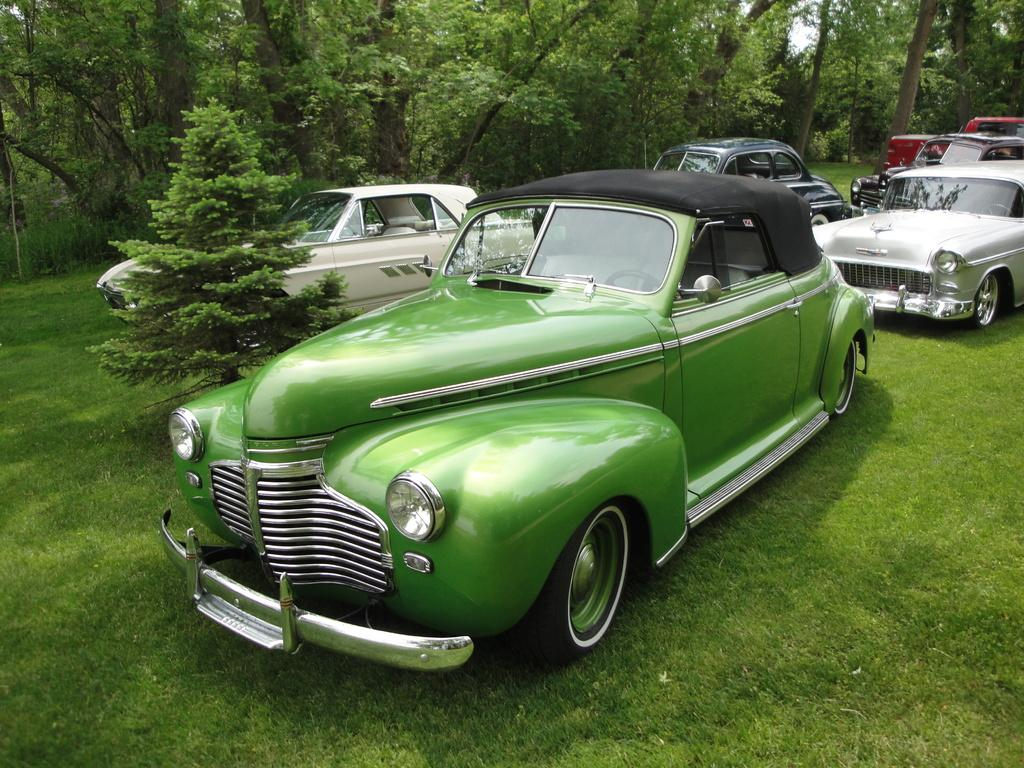What is located on the grass in the image? There are vehicles on the grass in the image. What type of natural elements can be seen in the image? There are trees and plants in the image. What can be seen in the background of the image? The sky is visible in the background of the image. What type of secretary can be seen working in the image? There is no secretary present in the image. What news is being reported in the image? There is no news being reported in the image. 